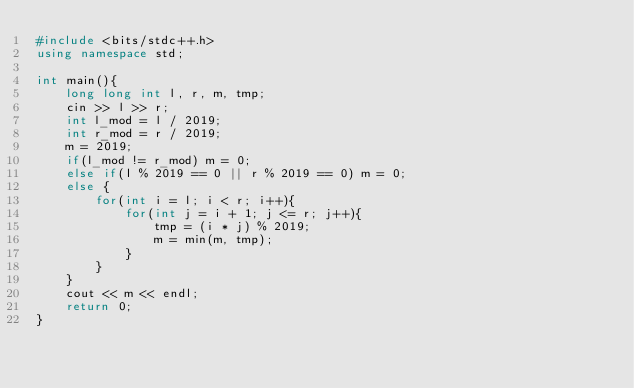Convert code to text. <code><loc_0><loc_0><loc_500><loc_500><_C++_>#include <bits/stdc++.h>
using namespace std;  

int main(){
    long long int l, r, m, tmp;
    cin >> l >> r;
    int l_mod = l / 2019;
    int r_mod = r / 2019;
    m = 2019;
    if(l_mod != r_mod) m = 0;
    else if(l % 2019 == 0 || r % 2019 == 0) m = 0;
    else {
        for(int i = l; i < r; i++){
            for(int j = i + 1; j <= r; j++){
                tmp = (i * j) % 2019;
                m = min(m, tmp);
            }
        }
    }
    cout << m << endl;
    return 0;
}</code> 